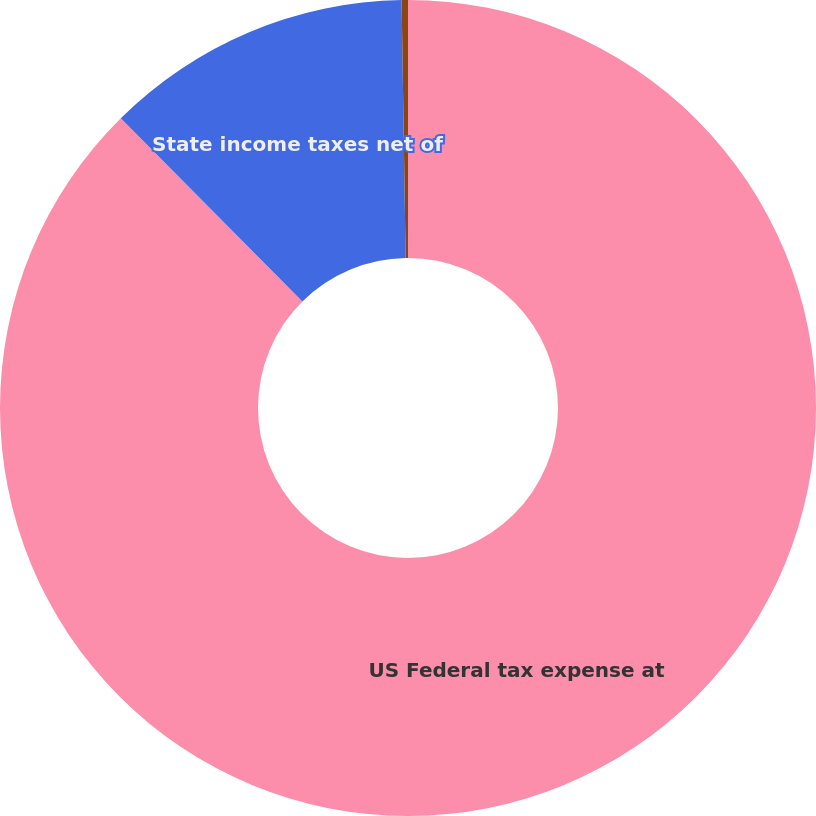Convert chart. <chart><loc_0><loc_0><loc_500><loc_500><pie_chart><fcel>US Federal tax expense at<fcel>State income taxes net of<fcel>Other<nl><fcel>87.57%<fcel>12.18%<fcel>0.25%<nl></chart> 